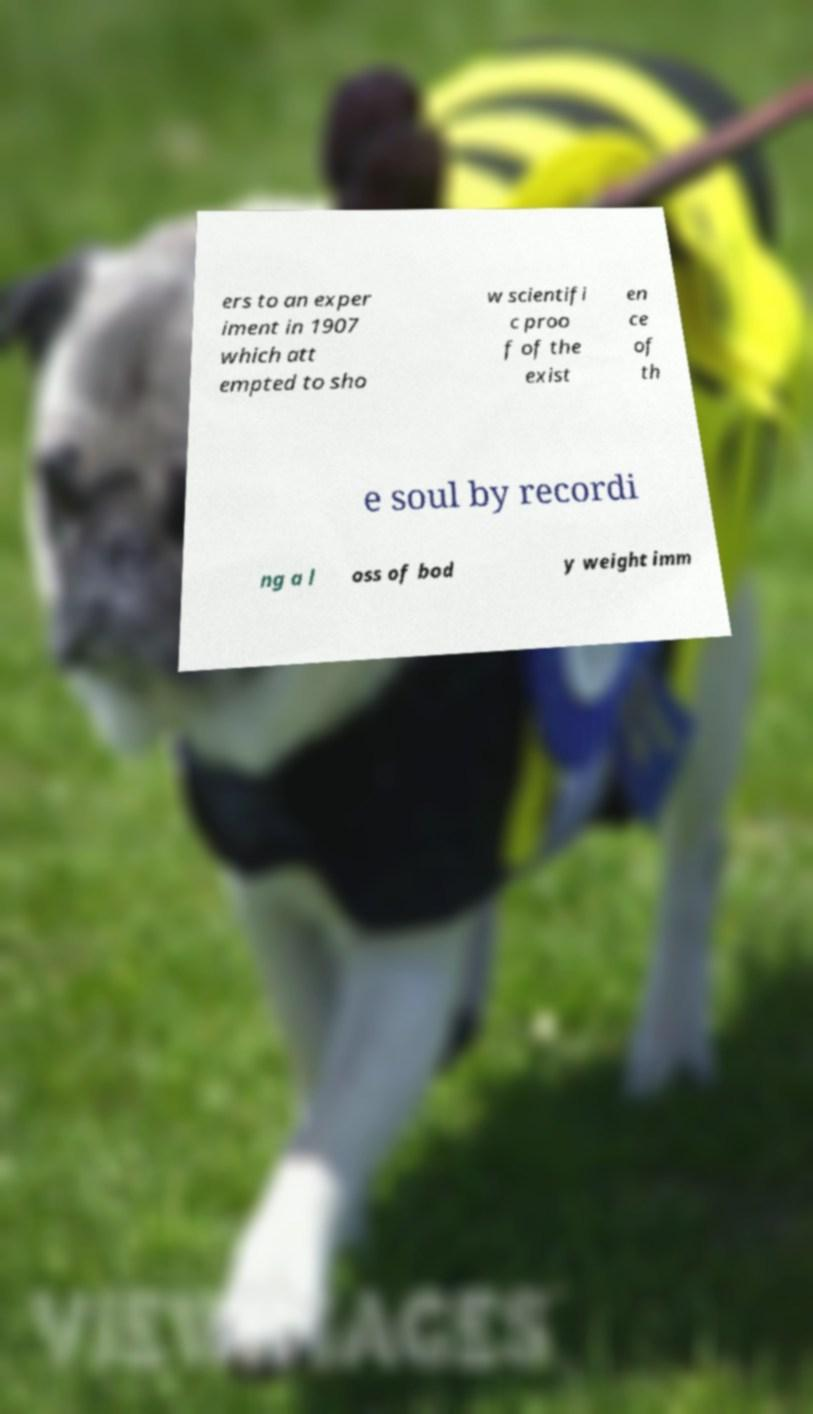Can you read and provide the text displayed in the image?This photo seems to have some interesting text. Can you extract and type it out for me? ers to an exper iment in 1907 which att empted to sho w scientifi c proo f of the exist en ce of th e soul by recordi ng a l oss of bod y weight imm 